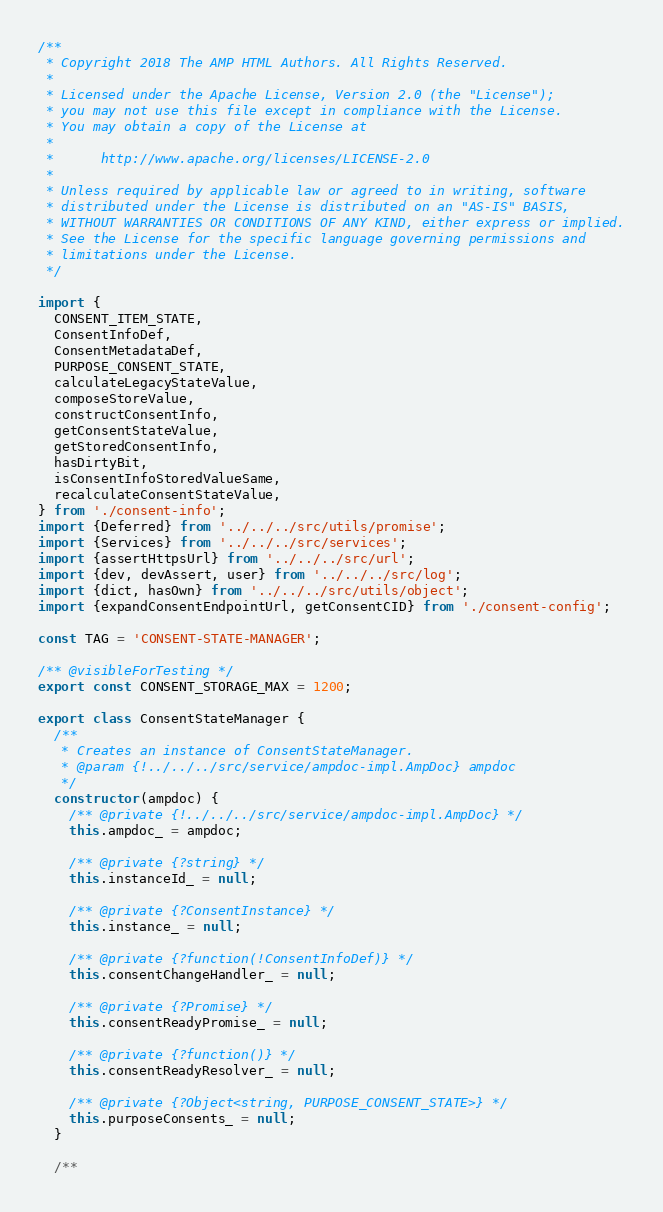Convert code to text. <code><loc_0><loc_0><loc_500><loc_500><_JavaScript_>/**
 * Copyright 2018 The AMP HTML Authors. All Rights Reserved.
 *
 * Licensed under the Apache License, Version 2.0 (the "License");
 * you may not use this file except in compliance with the License.
 * You may obtain a copy of the License at
 *
 *      http://www.apache.org/licenses/LICENSE-2.0
 *
 * Unless required by applicable law or agreed to in writing, software
 * distributed under the License is distributed on an "AS-IS" BASIS,
 * WITHOUT WARRANTIES OR CONDITIONS OF ANY KIND, either express or implied.
 * See the License for the specific language governing permissions and
 * limitations under the License.
 */

import {
  CONSENT_ITEM_STATE,
  ConsentInfoDef,
  ConsentMetadataDef,
  PURPOSE_CONSENT_STATE,
  calculateLegacyStateValue,
  composeStoreValue,
  constructConsentInfo,
  getConsentStateValue,
  getStoredConsentInfo,
  hasDirtyBit,
  isConsentInfoStoredValueSame,
  recalculateConsentStateValue,
} from './consent-info';
import {Deferred} from '../../../src/utils/promise';
import {Services} from '../../../src/services';
import {assertHttpsUrl} from '../../../src/url';
import {dev, devAssert, user} from '../../../src/log';
import {dict, hasOwn} from '../../../src/utils/object';
import {expandConsentEndpointUrl, getConsentCID} from './consent-config';

const TAG = 'CONSENT-STATE-MANAGER';

/** @visibleForTesting */
export const CONSENT_STORAGE_MAX = 1200;

export class ConsentStateManager {
  /**
   * Creates an instance of ConsentStateManager.
   * @param {!../../../src/service/ampdoc-impl.AmpDoc} ampdoc
   */
  constructor(ampdoc) {
    /** @private {!../../../src/service/ampdoc-impl.AmpDoc} */
    this.ampdoc_ = ampdoc;

    /** @private {?string} */
    this.instanceId_ = null;

    /** @private {?ConsentInstance} */
    this.instance_ = null;

    /** @private {?function(!ConsentInfoDef)} */
    this.consentChangeHandler_ = null;

    /** @private {?Promise} */
    this.consentReadyPromise_ = null;

    /** @private {?function()} */
    this.consentReadyResolver_ = null;

    /** @private {?Object<string, PURPOSE_CONSENT_STATE>} */
    this.purposeConsents_ = null;
  }

  /**</code> 